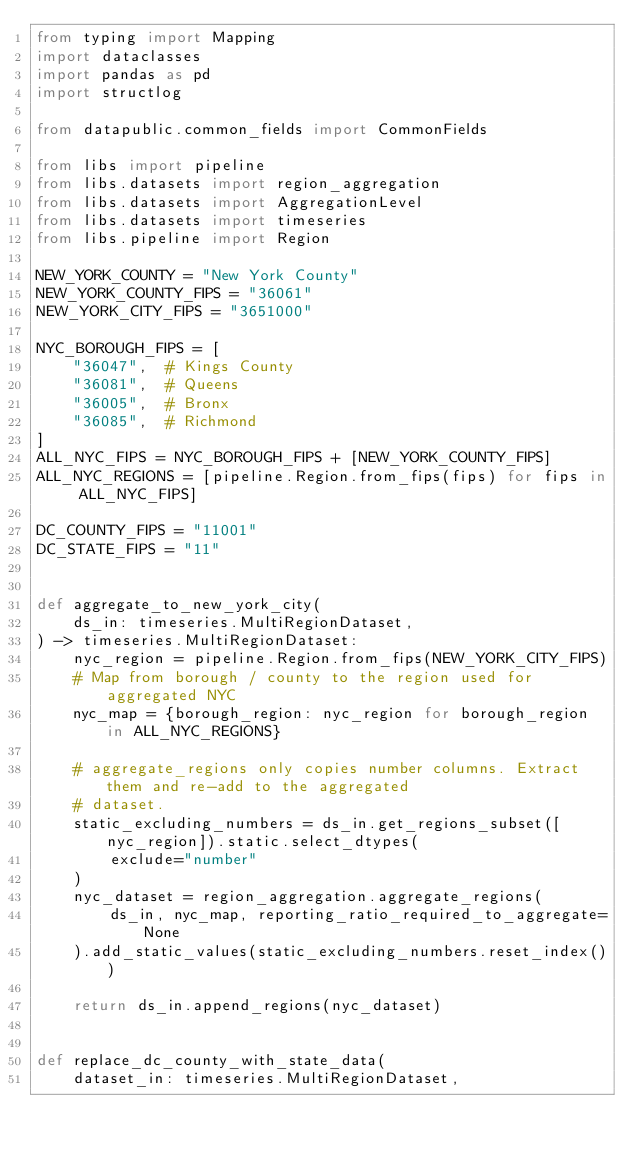Convert code to text. <code><loc_0><loc_0><loc_500><loc_500><_Python_>from typing import Mapping
import dataclasses
import pandas as pd
import structlog

from datapublic.common_fields import CommonFields

from libs import pipeline
from libs.datasets import region_aggregation
from libs.datasets import AggregationLevel
from libs.datasets import timeseries
from libs.pipeline import Region

NEW_YORK_COUNTY = "New York County"
NEW_YORK_COUNTY_FIPS = "36061"
NEW_YORK_CITY_FIPS = "3651000"

NYC_BOROUGH_FIPS = [
    "36047",  # Kings County
    "36081",  # Queens
    "36005",  # Bronx
    "36085",  # Richmond
]
ALL_NYC_FIPS = NYC_BOROUGH_FIPS + [NEW_YORK_COUNTY_FIPS]
ALL_NYC_REGIONS = [pipeline.Region.from_fips(fips) for fips in ALL_NYC_FIPS]

DC_COUNTY_FIPS = "11001"
DC_STATE_FIPS = "11"


def aggregate_to_new_york_city(
    ds_in: timeseries.MultiRegionDataset,
) -> timeseries.MultiRegionDataset:
    nyc_region = pipeline.Region.from_fips(NEW_YORK_CITY_FIPS)
    # Map from borough / county to the region used for aggregated NYC
    nyc_map = {borough_region: nyc_region for borough_region in ALL_NYC_REGIONS}

    # aggregate_regions only copies number columns. Extract them and re-add to the aggregated
    # dataset.
    static_excluding_numbers = ds_in.get_regions_subset([nyc_region]).static.select_dtypes(
        exclude="number"
    )
    nyc_dataset = region_aggregation.aggregate_regions(
        ds_in, nyc_map, reporting_ratio_required_to_aggregate=None
    ).add_static_values(static_excluding_numbers.reset_index())

    return ds_in.append_regions(nyc_dataset)


def replace_dc_county_with_state_data(
    dataset_in: timeseries.MultiRegionDataset,</code> 